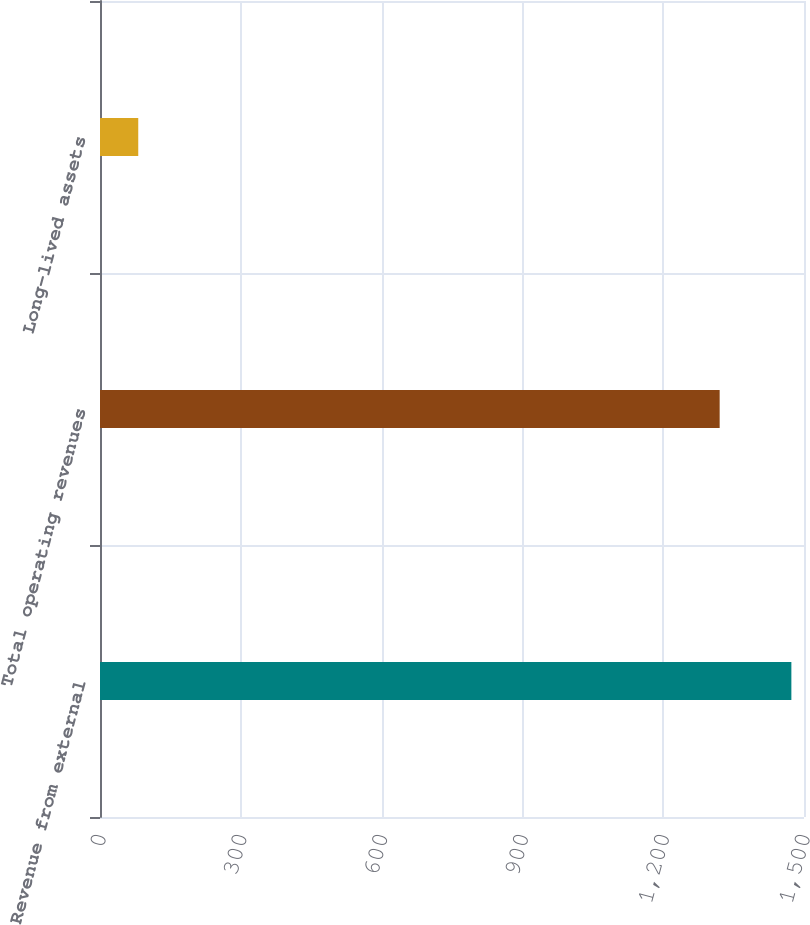Convert chart to OTSL. <chart><loc_0><loc_0><loc_500><loc_500><bar_chart><fcel>Revenue from external<fcel>Total operating revenues<fcel>Long-lived assets<nl><fcel>1473.1<fcel>1320.3<fcel>81.5<nl></chart> 